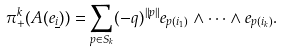Convert formula to latex. <formula><loc_0><loc_0><loc_500><loc_500>\pi _ { + } ^ { k } ( A ( e _ { \underline { i } } ) ) = \sum _ { p \in S _ { k } } ( - q ) ^ { \| p \| } e _ { p ( i _ { 1 } ) } \wedge \cdots \wedge e _ { p ( i _ { k } ) } .</formula> 